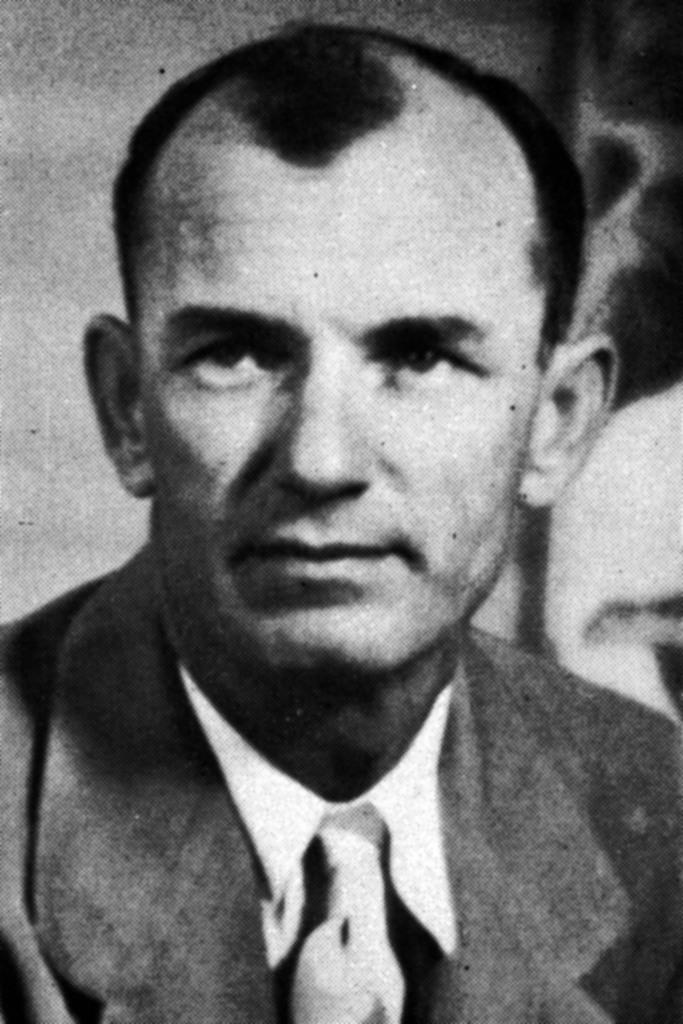Can you describe this image briefly? This is a black and white picture of a person in a suit. 